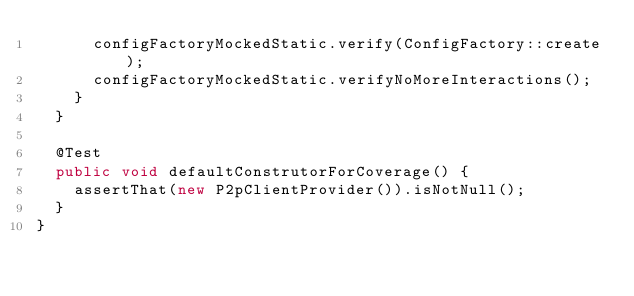Convert code to text. <code><loc_0><loc_0><loc_500><loc_500><_Java_>      configFactoryMockedStatic.verify(ConfigFactory::create);
      configFactoryMockedStatic.verifyNoMoreInteractions();
    }
  }

  @Test
  public void defaultConstrutorForCoverage() {
    assertThat(new P2pClientProvider()).isNotNull();
  }
}
</code> 